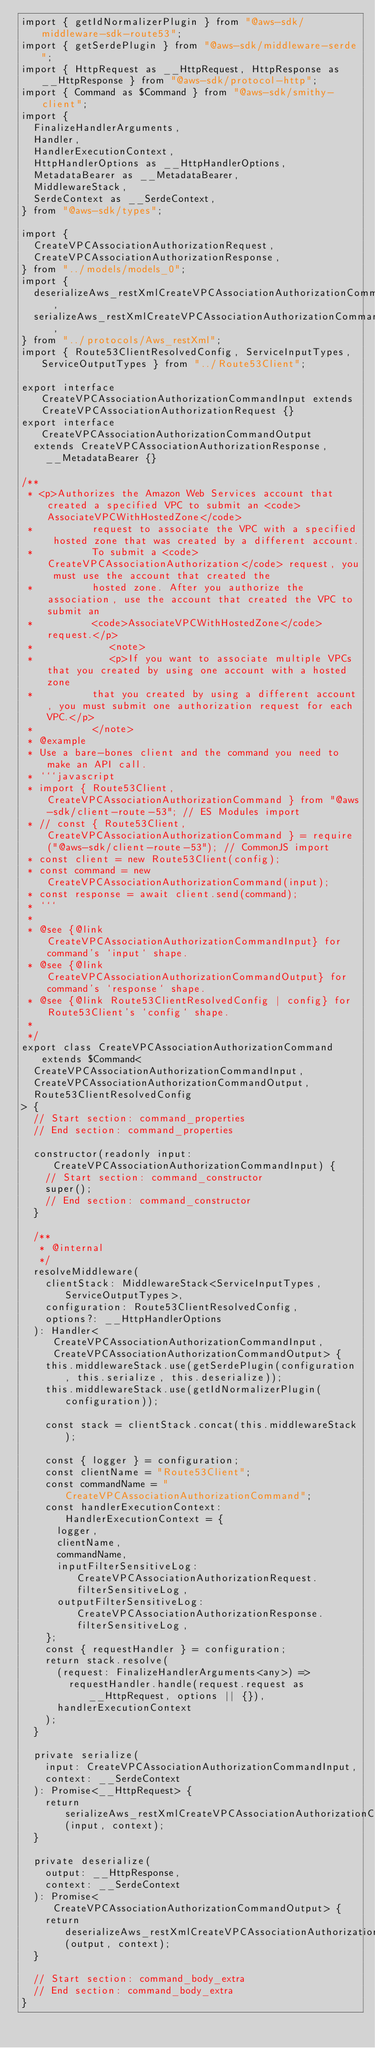<code> <loc_0><loc_0><loc_500><loc_500><_TypeScript_>import { getIdNormalizerPlugin } from "@aws-sdk/middleware-sdk-route53";
import { getSerdePlugin } from "@aws-sdk/middleware-serde";
import { HttpRequest as __HttpRequest, HttpResponse as __HttpResponse } from "@aws-sdk/protocol-http";
import { Command as $Command } from "@aws-sdk/smithy-client";
import {
  FinalizeHandlerArguments,
  Handler,
  HandlerExecutionContext,
  HttpHandlerOptions as __HttpHandlerOptions,
  MetadataBearer as __MetadataBearer,
  MiddlewareStack,
  SerdeContext as __SerdeContext,
} from "@aws-sdk/types";

import {
  CreateVPCAssociationAuthorizationRequest,
  CreateVPCAssociationAuthorizationResponse,
} from "../models/models_0";
import {
  deserializeAws_restXmlCreateVPCAssociationAuthorizationCommand,
  serializeAws_restXmlCreateVPCAssociationAuthorizationCommand,
} from "../protocols/Aws_restXml";
import { Route53ClientResolvedConfig, ServiceInputTypes, ServiceOutputTypes } from "../Route53Client";

export interface CreateVPCAssociationAuthorizationCommandInput extends CreateVPCAssociationAuthorizationRequest {}
export interface CreateVPCAssociationAuthorizationCommandOutput
  extends CreateVPCAssociationAuthorizationResponse,
    __MetadataBearer {}

/**
 * <p>Authorizes the Amazon Web Services account that created a specified VPC to submit an <code>AssociateVPCWithHostedZone</code>
 * 			request to associate the VPC with a specified hosted zone that was created by a different account.
 * 			To submit a <code>CreateVPCAssociationAuthorization</code> request, you must use the account that created the
 * 			hosted zone. After you authorize the association, use the account that created the VPC to submit an
 * 			<code>AssociateVPCWithHostedZone</code> request.</p>
 * 		       <note>
 *             <p>If you want to associate multiple VPCs that you created by using one account with a hosted zone
 * 			that you created by using a different account, you must submit one authorization request for each VPC.</p>
 *          </note>
 * @example
 * Use a bare-bones client and the command you need to make an API call.
 * ```javascript
 * import { Route53Client, CreateVPCAssociationAuthorizationCommand } from "@aws-sdk/client-route-53"; // ES Modules import
 * // const { Route53Client, CreateVPCAssociationAuthorizationCommand } = require("@aws-sdk/client-route-53"); // CommonJS import
 * const client = new Route53Client(config);
 * const command = new CreateVPCAssociationAuthorizationCommand(input);
 * const response = await client.send(command);
 * ```
 *
 * @see {@link CreateVPCAssociationAuthorizationCommandInput} for command's `input` shape.
 * @see {@link CreateVPCAssociationAuthorizationCommandOutput} for command's `response` shape.
 * @see {@link Route53ClientResolvedConfig | config} for Route53Client's `config` shape.
 *
 */
export class CreateVPCAssociationAuthorizationCommand extends $Command<
  CreateVPCAssociationAuthorizationCommandInput,
  CreateVPCAssociationAuthorizationCommandOutput,
  Route53ClientResolvedConfig
> {
  // Start section: command_properties
  // End section: command_properties

  constructor(readonly input: CreateVPCAssociationAuthorizationCommandInput) {
    // Start section: command_constructor
    super();
    // End section: command_constructor
  }

  /**
   * @internal
   */
  resolveMiddleware(
    clientStack: MiddlewareStack<ServiceInputTypes, ServiceOutputTypes>,
    configuration: Route53ClientResolvedConfig,
    options?: __HttpHandlerOptions
  ): Handler<CreateVPCAssociationAuthorizationCommandInput, CreateVPCAssociationAuthorizationCommandOutput> {
    this.middlewareStack.use(getSerdePlugin(configuration, this.serialize, this.deserialize));
    this.middlewareStack.use(getIdNormalizerPlugin(configuration));

    const stack = clientStack.concat(this.middlewareStack);

    const { logger } = configuration;
    const clientName = "Route53Client";
    const commandName = "CreateVPCAssociationAuthorizationCommand";
    const handlerExecutionContext: HandlerExecutionContext = {
      logger,
      clientName,
      commandName,
      inputFilterSensitiveLog: CreateVPCAssociationAuthorizationRequest.filterSensitiveLog,
      outputFilterSensitiveLog: CreateVPCAssociationAuthorizationResponse.filterSensitiveLog,
    };
    const { requestHandler } = configuration;
    return stack.resolve(
      (request: FinalizeHandlerArguments<any>) =>
        requestHandler.handle(request.request as __HttpRequest, options || {}),
      handlerExecutionContext
    );
  }

  private serialize(
    input: CreateVPCAssociationAuthorizationCommandInput,
    context: __SerdeContext
  ): Promise<__HttpRequest> {
    return serializeAws_restXmlCreateVPCAssociationAuthorizationCommand(input, context);
  }

  private deserialize(
    output: __HttpResponse,
    context: __SerdeContext
  ): Promise<CreateVPCAssociationAuthorizationCommandOutput> {
    return deserializeAws_restXmlCreateVPCAssociationAuthorizationCommand(output, context);
  }

  // Start section: command_body_extra
  // End section: command_body_extra
}
</code> 